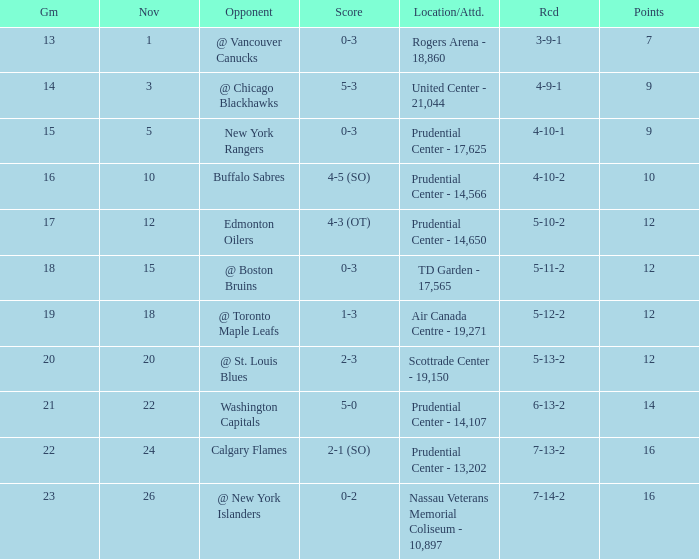What is the record that had a score of 5-3? 4-9-1. 